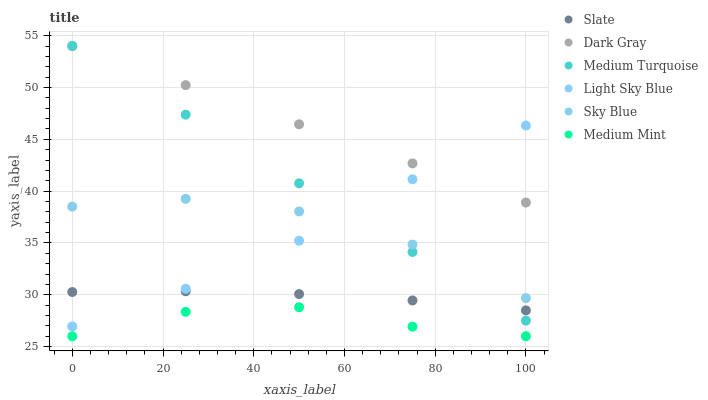Does Medium Mint have the minimum area under the curve?
Answer yes or no. Yes. Does Dark Gray have the maximum area under the curve?
Answer yes or no. Yes. Does Slate have the minimum area under the curve?
Answer yes or no. No. Does Slate have the maximum area under the curve?
Answer yes or no. No. Is Dark Gray the smoothest?
Answer yes or no. Yes. Is Sky Blue the roughest?
Answer yes or no. Yes. Is Slate the smoothest?
Answer yes or no. No. Is Slate the roughest?
Answer yes or no. No. Does Medium Mint have the lowest value?
Answer yes or no. Yes. Does Slate have the lowest value?
Answer yes or no. No. Does Medium Turquoise have the highest value?
Answer yes or no. Yes. Does Slate have the highest value?
Answer yes or no. No. Is Medium Mint less than Light Sky Blue?
Answer yes or no. Yes. Is Medium Turquoise greater than Medium Mint?
Answer yes or no. Yes. Does Dark Gray intersect Medium Turquoise?
Answer yes or no. Yes. Is Dark Gray less than Medium Turquoise?
Answer yes or no. No. Is Dark Gray greater than Medium Turquoise?
Answer yes or no. No. Does Medium Mint intersect Light Sky Blue?
Answer yes or no. No. 